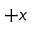<formula> <loc_0><loc_0><loc_500><loc_500>+ x</formula> 